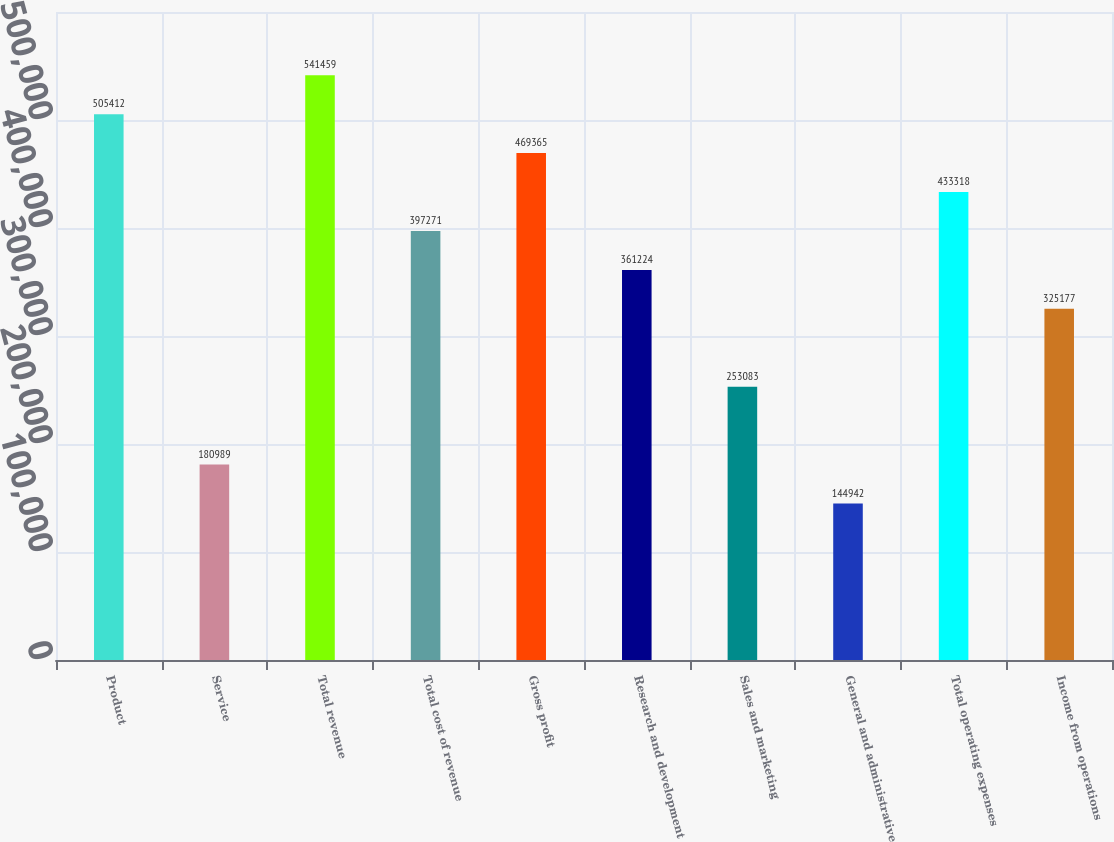<chart> <loc_0><loc_0><loc_500><loc_500><bar_chart><fcel>Product<fcel>Service<fcel>Total revenue<fcel>Total cost of revenue<fcel>Gross profit<fcel>Research and development<fcel>Sales and marketing<fcel>General and administrative<fcel>Total operating expenses<fcel>Income from operations<nl><fcel>505412<fcel>180989<fcel>541459<fcel>397271<fcel>469365<fcel>361224<fcel>253083<fcel>144942<fcel>433318<fcel>325177<nl></chart> 